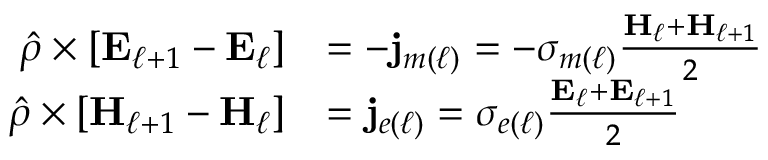<formula> <loc_0><loc_0><loc_500><loc_500>\begin{array} { r l } { \hat { \rho } \times \left [ E _ { \ell + 1 } - E _ { \ell } \right ] } & { = - j _ { m ( \ell ) } = - \sigma _ { m ( \ell ) } \frac { H _ { \ell } + H _ { \ell + 1 } } { 2 } } \\ { \hat { \rho } \times \left [ H _ { \ell + 1 } - H _ { \ell } \right ] } & { = j _ { e ( \ell ) } = \sigma _ { e ( \ell ) } \frac { E _ { \ell } + E _ { \ell + 1 } } { 2 } } \end{array}</formula> 